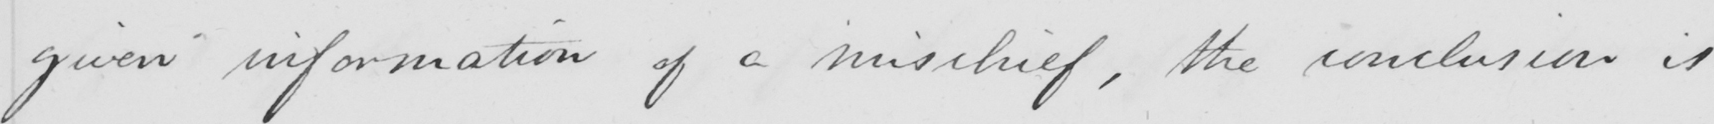Can you read and transcribe this handwriting? given information of a mischief , the conclusion is 